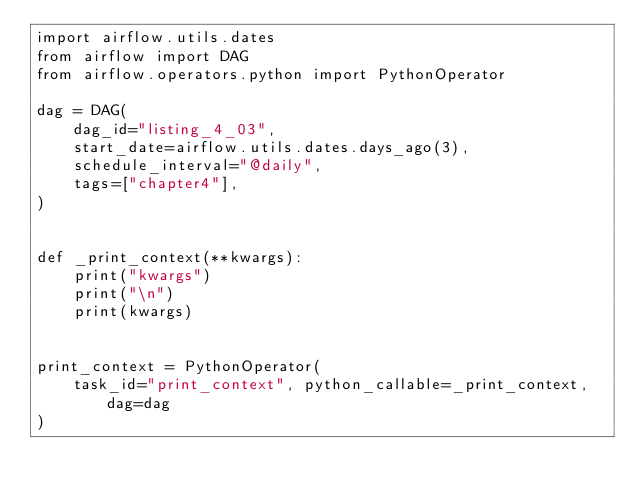<code> <loc_0><loc_0><loc_500><loc_500><_Python_>import airflow.utils.dates
from airflow import DAG
from airflow.operators.python import PythonOperator

dag = DAG(
    dag_id="listing_4_03",
    start_date=airflow.utils.dates.days_ago(3),
    schedule_interval="@daily",
    tags=["chapter4"],
)


def _print_context(**kwargs):
    print("kwargs")
    print("\n")
    print(kwargs)


print_context = PythonOperator(
    task_id="print_context", python_callable=_print_context, dag=dag
)
</code> 